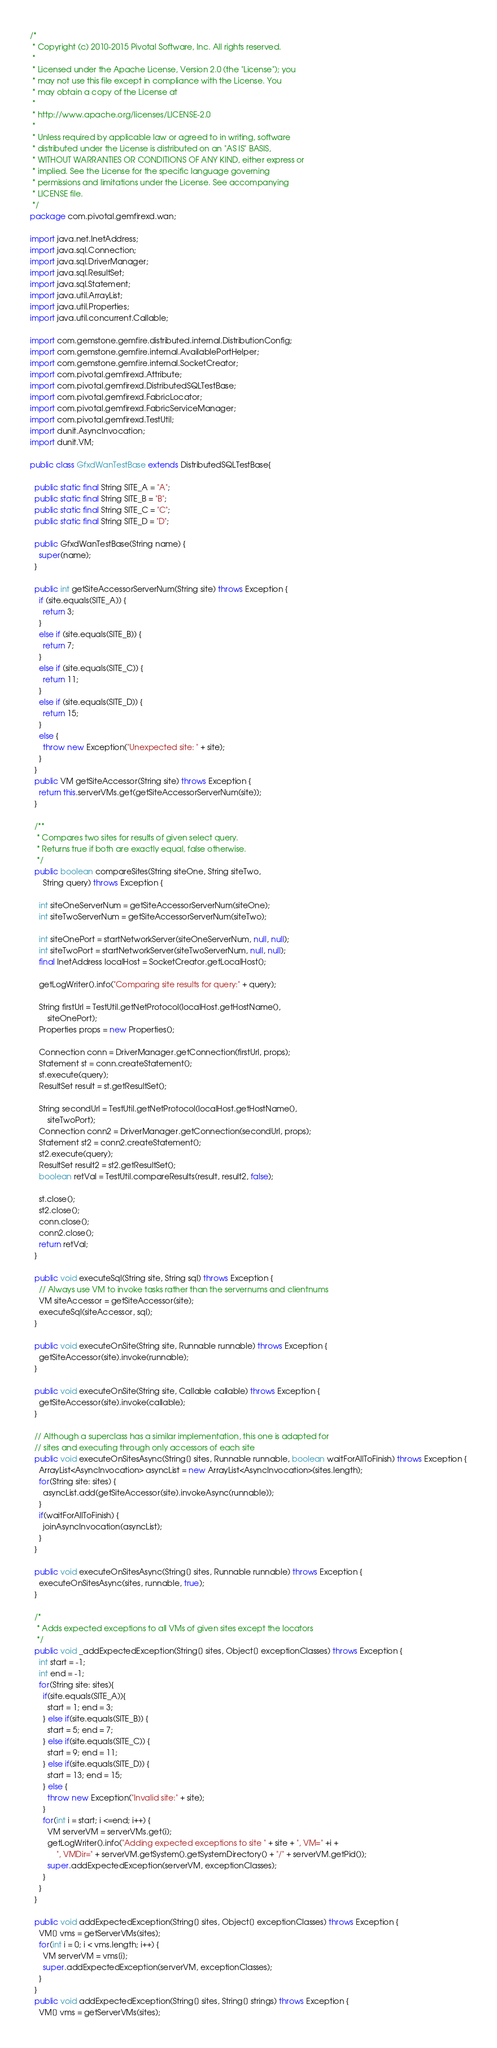<code> <loc_0><loc_0><loc_500><loc_500><_Java_>/*
 * Copyright (c) 2010-2015 Pivotal Software, Inc. All rights reserved.
 *
 * Licensed under the Apache License, Version 2.0 (the "License"); you
 * may not use this file except in compliance with the License. You
 * may obtain a copy of the License at
 *
 * http://www.apache.org/licenses/LICENSE-2.0
 *
 * Unless required by applicable law or agreed to in writing, software
 * distributed under the License is distributed on an "AS IS" BASIS,
 * WITHOUT WARRANTIES OR CONDITIONS OF ANY KIND, either express or
 * implied. See the License for the specific language governing
 * permissions and limitations under the License. See accompanying
 * LICENSE file.
 */
package com.pivotal.gemfirexd.wan;

import java.net.InetAddress;
import java.sql.Connection;
import java.sql.DriverManager;
import java.sql.ResultSet;
import java.sql.Statement;
import java.util.ArrayList;
import java.util.Properties;
import java.util.concurrent.Callable;

import com.gemstone.gemfire.distributed.internal.DistributionConfig;
import com.gemstone.gemfire.internal.AvailablePortHelper;
import com.gemstone.gemfire.internal.SocketCreator;
import com.pivotal.gemfirexd.Attribute;
import com.pivotal.gemfirexd.DistributedSQLTestBase;
import com.pivotal.gemfirexd.FabricLocator;
import com.pivotal.gemfirexd.FabricServiceManager;
import com.pivotal.gemfirexd.TestUtil;
import dunit.AsyncInvocation;
import dunit.VM;

public class GfxdWanTestBase extends DistributedSQLTestBase{
  
  public static final String SITE_A = "A";
  public static final String SITE_B = "B";
  public static final String SITE_C = "C";
  public static final String SITE_D = "D";
  
  public GfxdWanTestBase(String name) {
    super(name);
  }
  
  public int getSiteAccessorServerNum(String site) throws Exception {
    if (site.equals(SITE_A)) {
      return 3;
    }
    else if (site.equals(SITE_B)) {
      return 7;
    }
    else if (site.equals(SITE_C)) {
      return 11;
    }
    else if (site.equals(SITE_D)) {
      return 15;
    }
    else {
      throw new Exception("Unexpected site: " + site);
    }
  }
  public VM getSiteAccessor(String site) throws Exception {
    return this.serverVMs.get(getSiteAccessorServerNum(site));
  }

  /**
   * Compares two sites for results of given select query.
   * Returns true if both are exactly equal, false otherwise. 
   */
  public boolean compareSites(String siteOne, String siteTwo,
      String query) throws Exception {
    
    int siteOneServerNum = getSiteAccessorServerNum(siteOne);
    int siteTwoServerNum = getSiteAccessorServerNum(siteTwo);
    
    int siteOnePort = startNetworkServer(siteOneServerNum, null, null);
    int siteTwoPort = startNetworkServer(siteTwoServerNum, null, null);
    final InetAddress localHost = SocketCreator.getLocalHost();

    getLogWriter().info("Comparing site results for query:" + query);

    String firstUrl = TestUtil.getNetProtocol(localHost.getHostName(),
        siteOnePort);
    Properties props = new Properties();

    Connection conn = DriverManager.getConnection(firstUrl, props);
    Statement st = conn.createStatement();
    st.execute(query);
    ResultSet result = st.getResultSet();

    String secondUrl = TestUtil.getNetProtocol(localHost.getHostName(),
        siteTwoPort);
    Connection conn2 = DriverManager.getConnection(secondUrl, props);
    Statement st2 = conn2.createStatement();
    st2.execute(query);
    ResultSet result2 = st2.getResultSet();
    boolean retVal = TestUtil.compareResults(result, result2, false);

    st.close();
    st2.close();
    conn.close();
    conn2.close();
    return retVal;
  }

  public void executeSql(String site, String sql) throws Exception {
    // Always use VM to invoke tasks rather than the servernums and clientnums
    VM siteAccessor = getSiteAccessor(site);
    executeSql(siteAccessor, sql);
  }
  
  public void executeOnSite(String site, Runnable runnable) throws Exception {
    getSiteAccessor(site).invoke(runnable);
  }

  public void executeOnSite(String site, Callable callable) throws Exception {
    getSiteAccessor(site).invoke(callable);
  }

  // Although a superclass has a similar implementation, this one is adapted for
  // sites and executing through only accessors of each site
  public void executeOnSitesAsync(String[] sites, Runnable runnable, boolean waitForAllToFinish) throws Exception {
    ArrayList<AsyncInvocation> asyncList = new ArrayList<AsyncInvocation>(sites.length);
    for(String site: sites) {
      asyncList.add(getSiteAccessor(site).invokeAsync(runnable));
    }
    if(waitForAllToFinish) {
      joinAsyncInvocation(asyncList);
    }
  }
  
  public void executeOnSitesAsync(String[] sites, Runnable runnable) throws Exception {
    executeOnSitesAsync(sites, runnable, true);
  }
  
  /*
   * Adds expected exceptions to all VMs of given sites except the locators
   */
  public void _addExpectedException(String[] sites, Object[] exceptionClasses) throws Exception {
    int start = -1;
    int end = -1;
    for(String site: sites){
      if(site.equals(SITE_A)){
        start = 1; end = 3;
      } else if(site.equals(SITE_B)) {
        start = 5; end = 7;
      } else if(site.equals(SITE_C)) {
        start = 9; end = 11;
      } else if(site.equals(SITE_D)) {
        start = 13; end = 15;
      } else {
        throw new Exception("Invalid site:" + site);
      }
      for(int i = start; i <=end; i++) {
        VM serverVM = serverVMs.get(i);
        getLogWriter().info("Adding expected exceptions to site " + site + ", VM=" +i + 
            ", VMDir=" + serverVM.getSystem().getSystemDirectory() + "/" + serverVM.getPid());
        super.addExpectedException(serverVM, exceptionClasses);
      }
    }
  }
  
  public void addExpectedException(String[] sites, Object[] exceptionClasses) throws Exception {
    VM[] vms = getServerVMs(sites);
    for(int i = 0; i < vms.length; i++) {
      VM serverVM = vms[i];
      super.addExpectedException(serverVM, exceptionClasses);
    }
  }
  public void addExpectedException(String[] sites, String[] strings) throws Exception {
    VM[] vms = getServerVMs(sites);</code> 